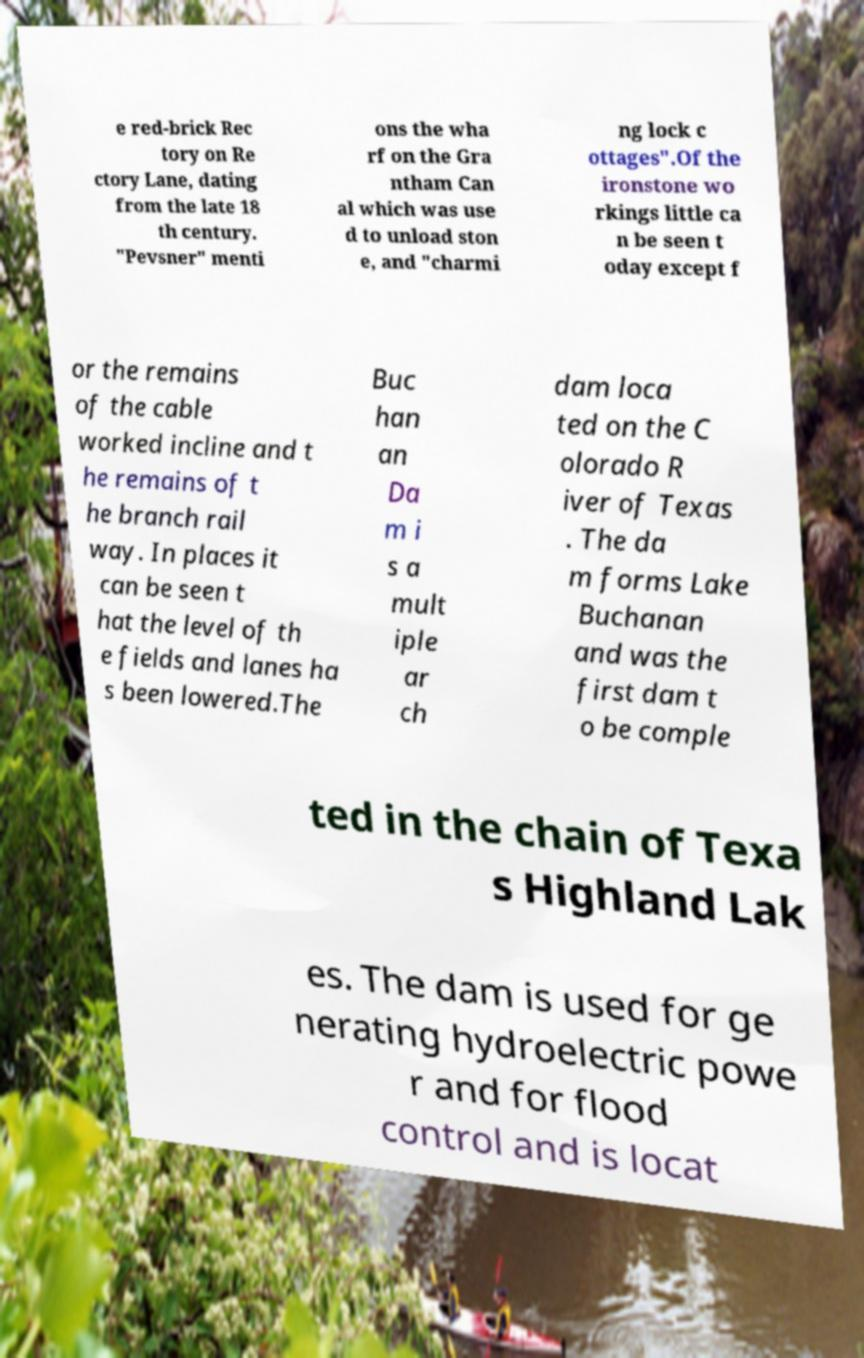I need the written content from this picture converted into text. Can you do that? e red-brick Rec tory on Re ctory Lane, dating from the late 18 th century. "Pevsner" menti ons the wha rf on the Gra ntham Can al which was use d to unload ston e, and "charmi ng lock c ottages".Of the ironstone wo rkings little ca n be seen t oday except f or the remains of the cable worked incline and t he remains of t he branch rail way. In places it can be seen t hat the level of th e fields and lanes ha s been lowered.The Buc han an Da m i s a mult iple ar ch dam loca ted on the C olorado R iver of Texas . The da m forms Lake Buchanan and was the first dam t o be comple ted in the chain of Texa s Highland Lak es. The dam is used for ge nerating hydroelectric powe r and for flood control and is locat 